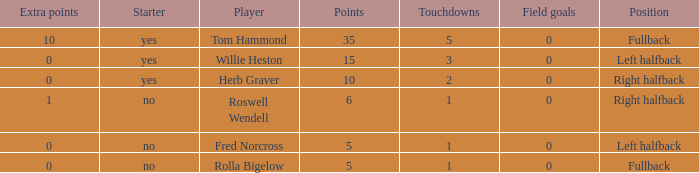Help me parse the entirety of this table. {'header': ['Extra points', 'Starter', 'Player', 'Points', 'Touchdowns', 'Field goals', 'Position'], 'rows': [['10', 'yes', 'Tom Hammond', '35', '5', '0', 'Fullback'], ['0', 'yes', 'Willie Heston', '15', '3', '0', 'Left halfback'], ['0', 'yes', 'Herb Graver', '10', '2', '0', 'Right halfback'], ['1', 'no', 'Roswell Wendell', '6', '1', '0', 'Right halfback'], ['0', 'no', 'Fred Norcross', '5', '1', '0', 'Left halfback'], ['0', 'no', 'Rolla Bigelow', '5', '1', '0', 'Fullback']]} What is the lowest number of field goals for a player with 3 touchdowns? 0.0. 